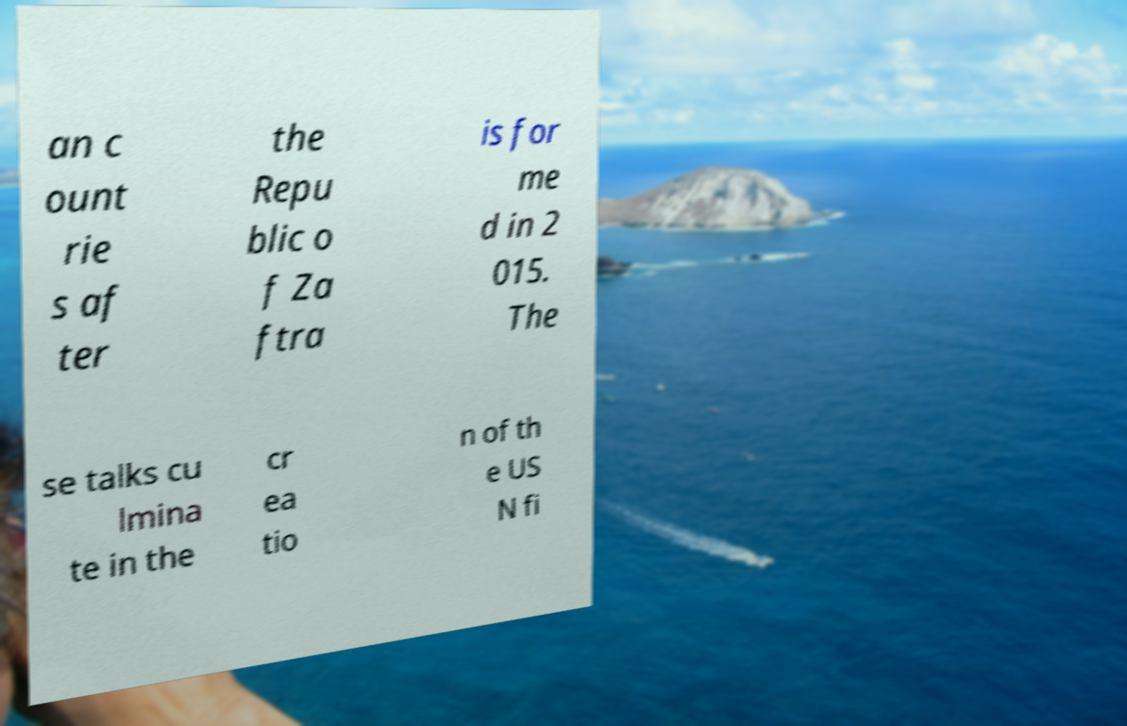Please identify and transcribe the text found in this image. an c ount rie s af ter the Repu blic o f Za ftra is for me d in 2 015. The se talks cu lmina te in the cr ea tio n of th e US N fi 